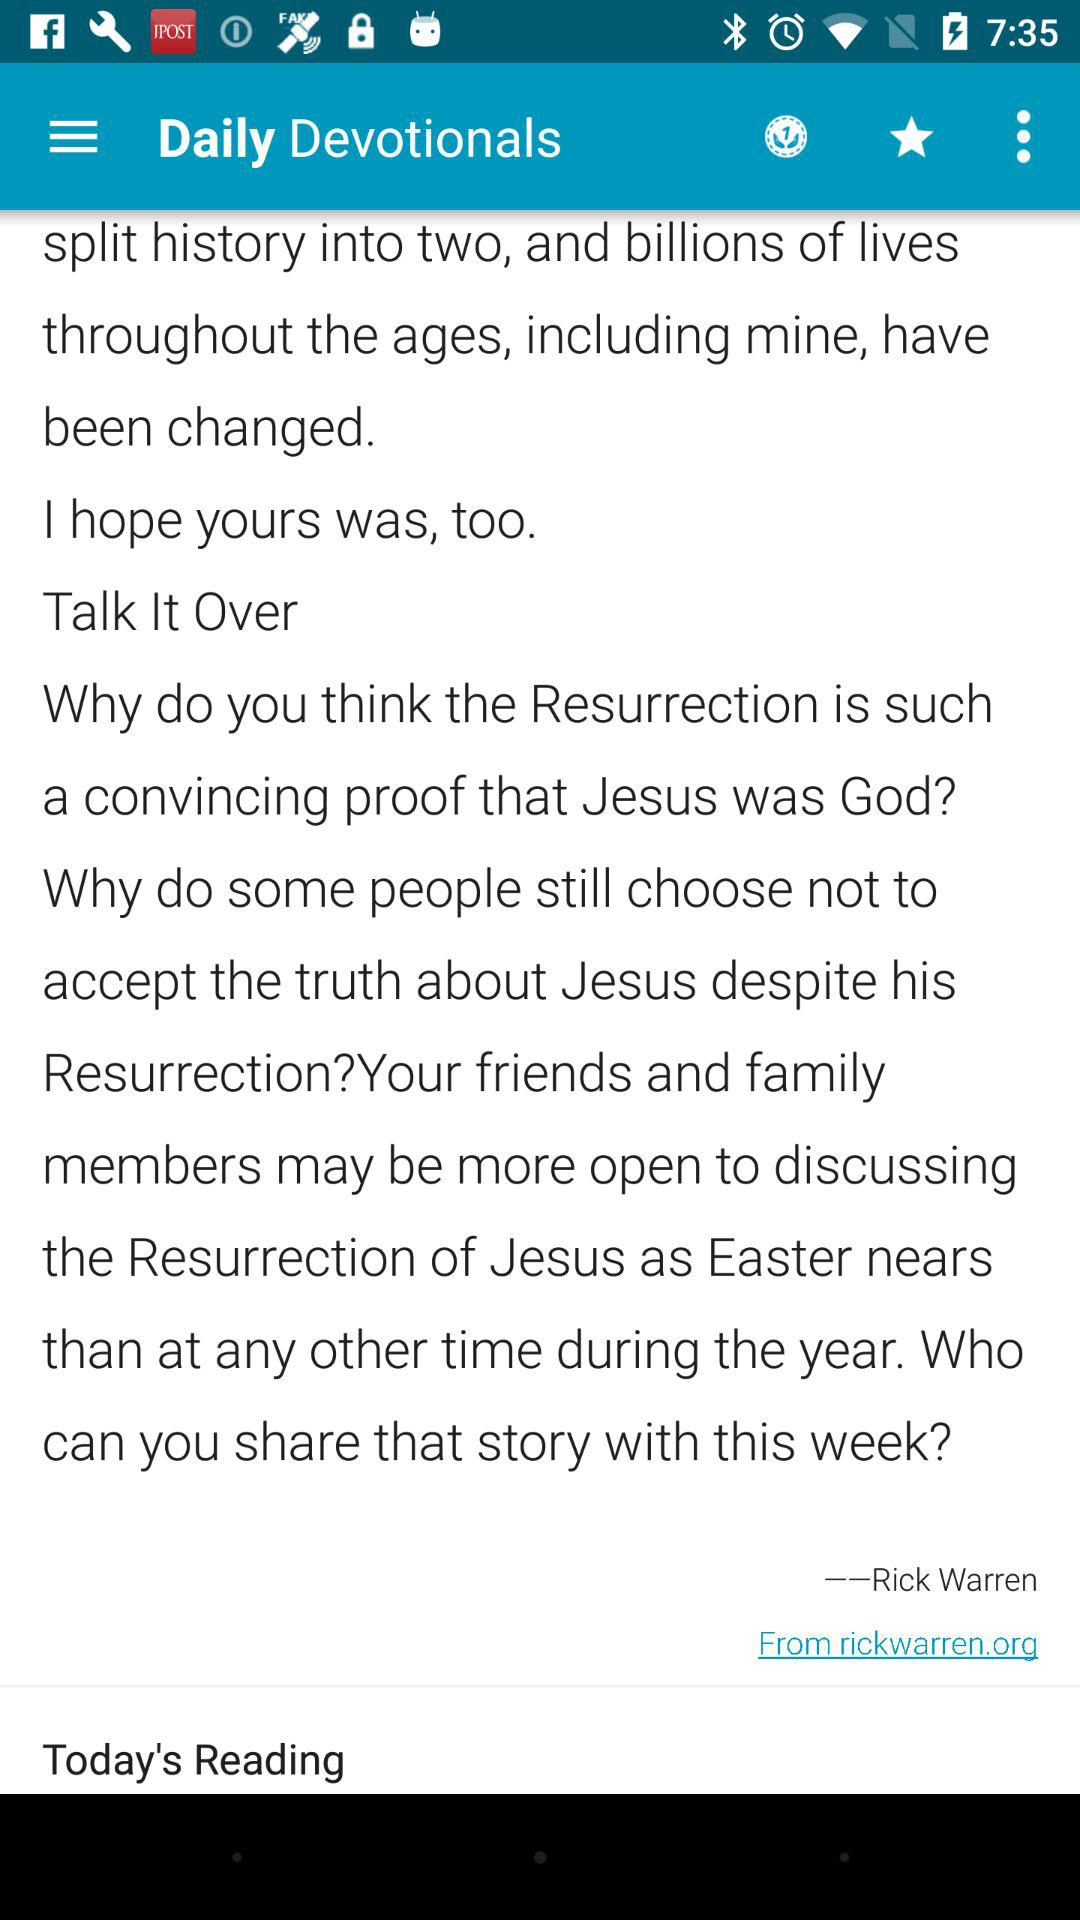Who is the author of the daily devotional blogs? The author is Rick Warren. 